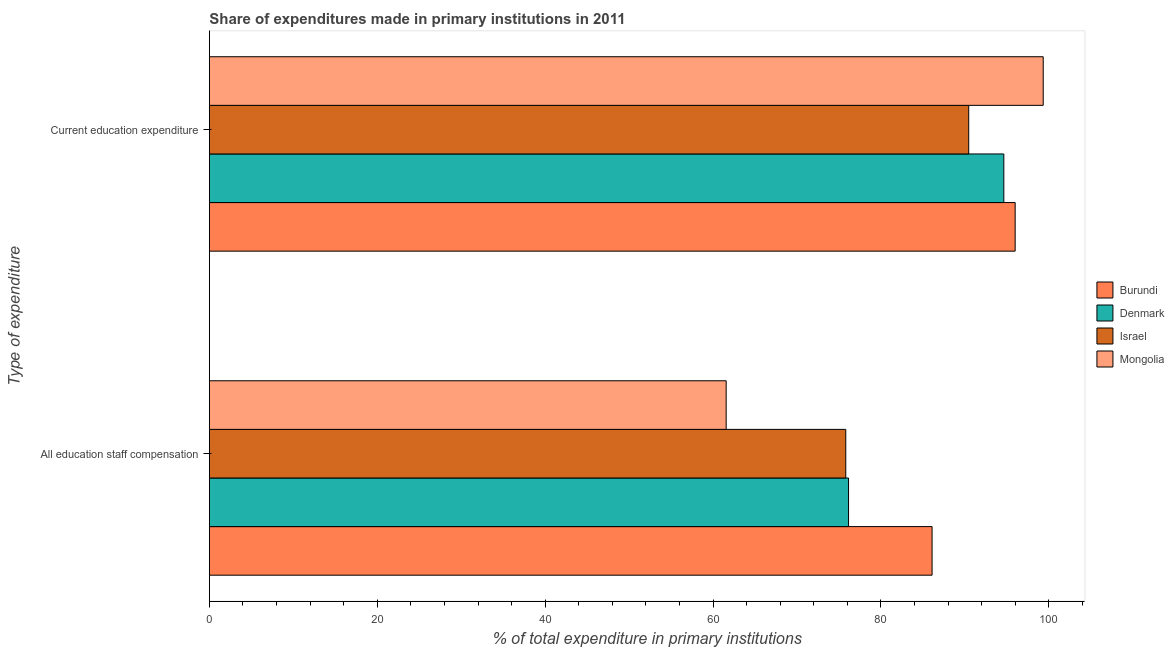How many groups of bars are there?
Keep it short and to the point. 2. Are the number of bars per tick equal to the number of legend labels?
Make the answer very short. Yes. What is the label of the 2nd group of bars from the top?
Your response must be concise. All education staff compensation. What is the expenditure in staff compensation in Mongolia?
Offer a terse response. 61.57. Across all countries, what is the maximum expenditure in education?
Offer a very short reply. 99.34. Across all countries, what is the minimum expenditure in staff compensation?
Offer a very short reply. 61.57. In which country was the expenditure in staff compensation maximum?
Ensure brevity in your answer.  Burundi. In which country was the expenditure in education minimum?
Offer a very short reply. Israel. What is the total expenditure in staff compensation in the graph?
Provide a succinct answer. 299.63. What is the difference between the expenditure in staff compensation in Burundi and that in Israel?
Make the answer very short. 10.28. What is the difference between the expenditure in staff compensation in Mongolia and the expenditure in education in Burundi?
Your response must be concise. -34.43. What is the average expenditure in staff compensation per country?
Ensure brevity in your answer.  74.91. What is the difference between the expenditure in education and expenditure in staff compensation in Denmark?
Offer a very short reply. 18.5. What is the ratio of the expenditure in education in Burundi to that in Israel?
Provide a succinct answer. 1.06. What does the 4th bar from the top in Current education expenditure represents?
Your answer should be very brief. Burundi. What does the 1st bar from the bottom in All education staff compensation represents?
Provide a succinct answer. Burundi. Are all the bars in the graph horizontal?
Offer a terse response. Yes. How many countries are there in the graph?
Give a very brief answer. 4. What is the difference between two consecutive major ticks on the X-axis?
Offer a terse response. 20. Are the values on the major ticks of X-axis written in scientific E-notation?
Offer a very short reply. No. Does the graph contain any zero values?
Provide a short and direct response. No. How are the legend labels stacked?
Offer a very short reply. Vertical. What is the title of the graph?
Give a very brief answer. Share of expenditures made in primary institutions in 2011. What is the label or title of the X-axis?
Keep it short and to the point. % of total expenditure in primary institutions. What is the label or title of the Y-axis?
Your answer should be compact. Type of expenditure. What is the % of total expenditure in primary institutions in Burundi in All education staff compensation?
Provide a short and direct response. 86.1. What is the % of total expenditure in primary institutions in Denmark in All education staff compensation?
Make the answer very short. 76.15. What is the % of total expenditure in primary institutions of Israel in All education staff compensation?
Your response must be concise. 75.82. What is the % of total expenditure in primary institutions in Mongolia in All education staff compensation?
Your response must be concise. 61.57. What is the % of total expenditure in primary institutions in Burundi in Current education expenditure?
Your response must be concise. 96. What is the % of total expenditure in primary institutions of Denmark in Current education expenditure?
Your answer should be very brief. 94.65. What is the % of total expenditure in primary institutions in Israel in Current education expenditure?
Give a very brief answer. 90.46. What is the % of total expenditure in primary institutions of Mongolia in Current education expenditure?
Provide a short and direct response. 99.34. Across all Type of expenditure, what is the maximum % of total expenditure in primary institutions of Burundi?
Ensure brevity in your answer.  96. Across all Type of expenditure, what is the maximum % of total expenditure in primary institutions in Denmark?
Offer a very short reply. 94.65. Across all Type of expenditure, what is the maximum % of total expenditure in primary institutions in Israel?
Your response must be concise. 90.46. Across all Type of expenditure, what is the maximum % of total expenditure in primary institutions in Mongolia?
Make the answer very short. 99.34. Across all Type of expenditure, what is the minimum % of total expenditure in primary institutions in Burundi?
Your answer should be very brief. 86.1. Across all Type of expenditure, what is the minimum % of total expenditure in primary institutions of Denmark?
Your response must be concise. 76.15. Across all Type of expenditure, what is the minimum % of total expenditure in primary institutions in Israel?
Keep it short and to the point. 75.82. Across all Type of expenditure, what is the minimum % of total expenditure in primary institutions of Mongolia?
Your response must be concise. 61.57. What is the total % of total expenditure in primary institutions in Burundi in the graph?
Give a very brief answer. 182.09. What is the total % of total expenditure in primary institutions in Denmark in the graph?
Provide a short and direct response. 170.79. What is the total % of total expenditure in primary institutions of Israel in the graph?
Your answer should be very brief. 166.28. What is the total % of total expenditure in primary institutions of Mongolia in the graph?
Offer a very short reply. 160.91. What is the difference between the % of total expenditure in primary institutions of Burundi in All education staff compensation and that in Current education expenditure?
Keep it short and to the point. -9.9. What is the difference between the % of total expenditure in primary institutions in Denmark in All education staff compensation and that in Current education expenditure?
Make the answer very short. -18.5. What is the difference between the % of total expenditure in primary institutions in Israel in All education staff compensation and that in Current education expenditure?
Provide a succinct answer. -14.65. What is the difference between the % of total expenditure in primary institutions in Mongolia in All education staff compensation and that in Current education expenditure?
Your answer should be very brief. -37.77. What is the difference between the % of total expenditure in primary institutions in Burundi in All education staff compensation and the % of total expenditure in primary institutions in Denmark in Current education expenditure?
Provide a short and direct response. -8.55. What is the difference between the % of total expenditure in primary institutions of Burundi in All education staff compensation and the % of total expenditure in primary institutions of Israel in Current education expenditure?
Give a very brief answer. -4.37. What is the difference between the % of total expenditure in primary institutions of Burundi in All education staff compensation and the % of total expenditure in primary institutions of Mongolia in Current education expenditure?
Make the answer very short. -13.24. What is the difference between the % of total expenditure in primary institutions in Denmark in All education staff compensation and the % of total expenditure in primary institutions in Israel in Current education expenditure?
Your response must be concise. -14.32. What is the difference between the % of total expenditure in primary institutions in Denmark in All education staff compensation and the % of total expenditure in primary institutions in Mongolia in Current education expenditure?
Ensure brevity in your answer.  -23.19. What is the difference between the % of total expenditure in primary institutions of Israel in All education staff compensation and the % of total expenditure in primary institutions of Mongolia in Current education expenditure?
Your answer should be very brief. -23.52. What is the average % of total expenditure in primary institutions in Burundi per Type of expenditure?
Make the answer very short. 91.05. What is the average % of total expenditure in primary institutions in Denmark per Type of expenditure?
Your answer should be very brief. 85.4. What is the average % of total expenditure in primary institutions of Israel per Type of expenditure?
Provide a succinct answer. 83.14. What is the average % of total expenditure in primary institutions in Mongolia per Type of expenditure?
Your answer should be compact. 80.45. What is the difference between the % of total expenditure in primary institutions in Burundi and % of total expenditure in primary institutions in Denmark in All education staff compensation?
Your answer should be very brief. 9.95. What is the difference between the % of total expenditure in primary institutions in Burundi and % of total expenditure in primary institutions in Israel in All education staff compensation?
Offer a terse response. 10.28. What is the difference between the % of total expenditure in primary institutions of Burundi and % of total expenditure in primary institutions of Mongolia in All education staff compensation?
Give a very brief answer. 24.53. What is the difference between the % of total expenditure in primary institutions in Denmark and % of total expenditure in primary institutions in Israel in All education staff compensation?
Your response must be concise. 0.33. What is the difference between the % of total expenditure in primary institutions of Denmark and % of total expenditure in primary institutions of Mongolia in All education staff compensation?
Keep it short and to the point. 14.58. What is the difference between the % of total expenditure in primary institutions in Israel and % of total expenditure in primary institutions in Mongolia in All education staff compensation?
Your response must be concise. 14.25. What is the difference between the % of total expenditure in primary institutions of Burundi and % of total expenditure in primary institutions of Denmark in Current education expenditure?
Your answer should be compact. 1.35. What is the difference between the % of total expenditure in primary institutions of Burundi and % of total expenditure in primary institutions of Israel in Current education expenditure?
Your answer should be compact. 5.53. What is the difference between the % of total expenditure in primary institutions in Burundi and % of total expenditure in primary institutions in Mongolia in Current education expenditure?
Your response must be concise. -3.34. What is the difference between the % of total expenditure in primary institutions of Denmark and % of total expenditure in primary institutions of Israel in Current education expenditure?
Ensure brevity in your answer.  4.18. What is the difference between the % of total expenditure in primary institutions in Denmark and % of total expenditure in primary institutions in Mongolia in Current education expenditure?
Make the answer very short. -4.69. What is the difference between the % of total expenditure in primary institutions of Israel and % of total expenditure in primary institutions of Mongolia in Current education expenditure?
Your response must be concise. -8.88. What is the ratio of the % of total expenditure in primary institutions of Burundi in All education staff compensation to that in Current education expenditure?
Your answer should be very brief. 0.9. What is the ratio of the % of total expenditure in primary institutions of Denmark in All education staff compensation to that in Current education expenditure?
Ensure brevity in your answer.  0.8. What is the ratio of the % of total expenditure in primary institutions of Israel in All education staff compensation to that in Current education expenditure?
Provide a short and direct response. 0.84. What is the ratio of the % of total expenditure in primary institutions in Mongolia in All education staff compensation to that in Current education expenditure?
Make the answer very short. 0.62. What is the difference between the highest and the second highest % of total expenditure in primary institutions of Burundi?
Give a very brief answer. 9.9. What is the difference between the highest and the second highest % of total expenditure in primary institutions of Denmark?
Your answer should be very brief. 18.5. What is the difference between the highest and the second highest % of total expenditure in primary institutions of Israel?
Keep it short and to the point. 14.65. What is the difference between the highest and the second highest % of total expenditure in primary institutions in Mongolia?
Your answer should be very brief. 37.77. What is the difference between the highest and the lowest % of total expenditure in primary institutions of Burundi?
Make the answer very short. 9.9. What is the difference between the highest and the lowest % of total expenditure in primary institutions in Denmark?
Offer a very short reply. 18.5. What is the difference between the highest and the lowest % of total expenditure in primary institutions of Israel?
Offer a very short reply. 14.65. What is the difference between the highest and the lowest % of total expenditure in primary institutions in Mongolia?
Provide a succinct answer. 37.77. 